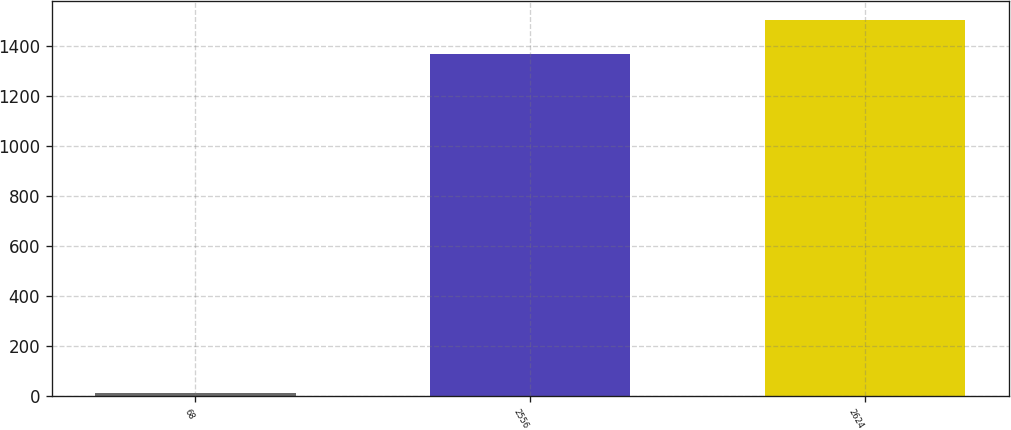Convert chart to OTSL. <chart><loc_0><loc_0><loc_500><loc_500><bar_chart><fcel>68<fcel>2556<fcel>2624<nl><fcel>11<fcel>1369<fcel>1505.9<nl></chart> 